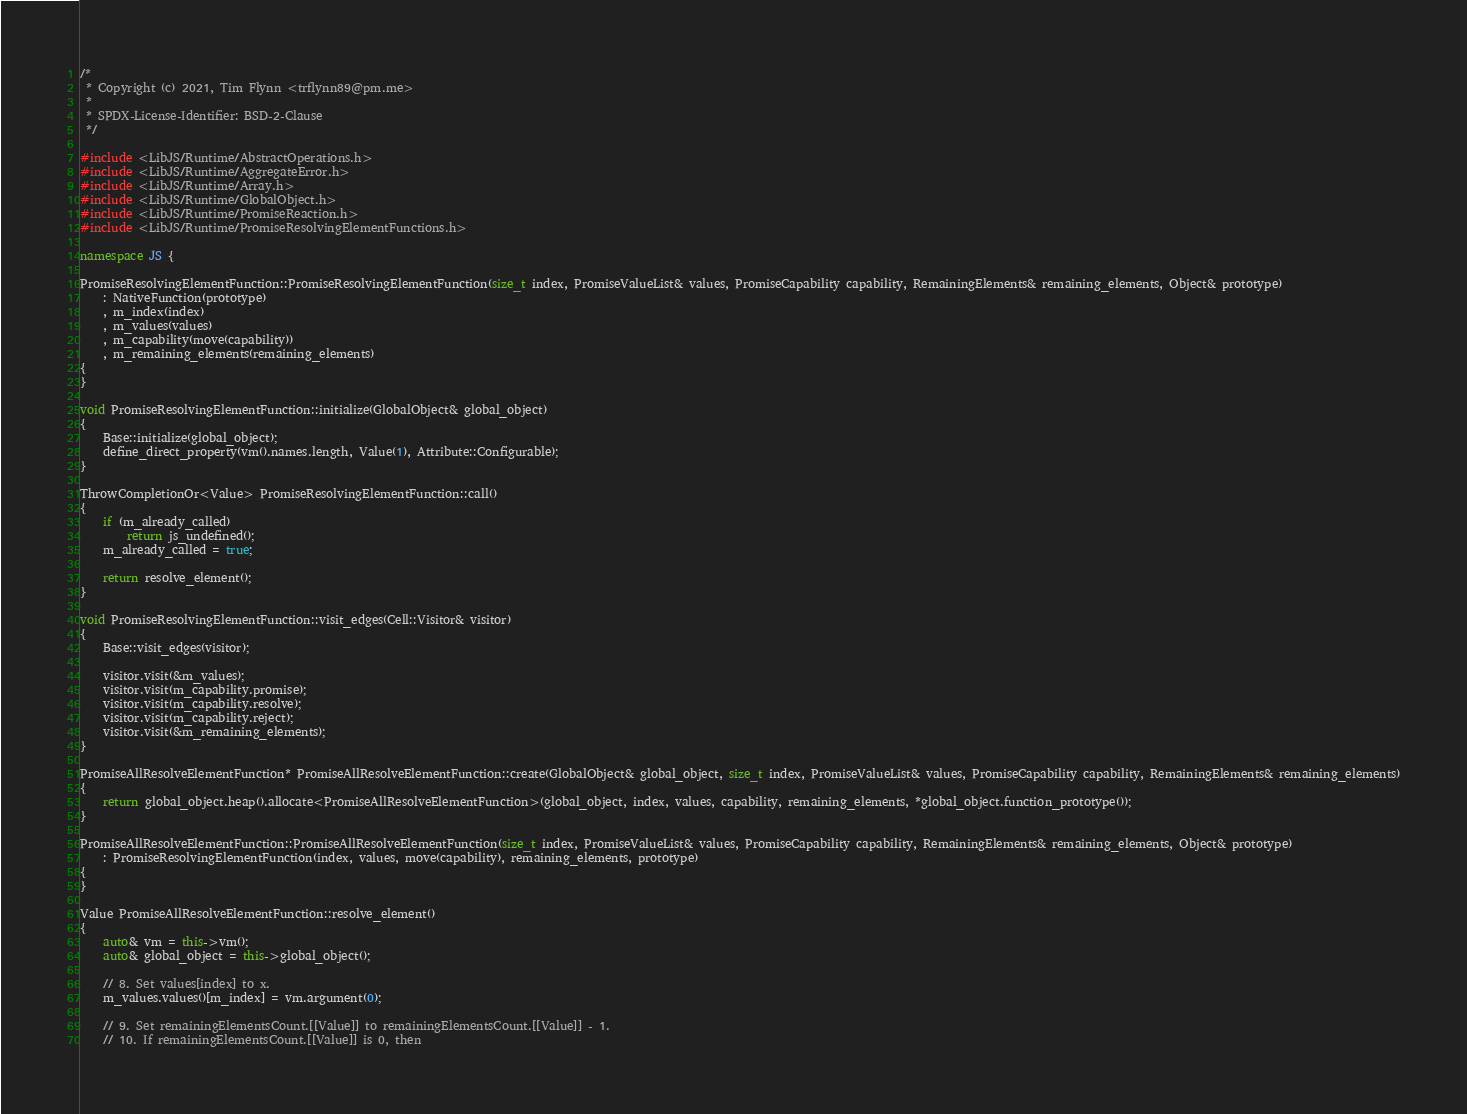<code> <loc_0><loc_0><loc_500><loc_500><_C++_>/*
 * Copyright (c) 2021, Tim Flynn <trflynn89@pm.me>
 *
 * SPDX-License-Identifier: BSD-2-Clause
 */

#include <LibJS/Runtime/AbstractOperations.h>
#include <LibJS/Runtime/AggregateError.h>
#include <LibJS/Runtime/Array.h>
#include <LibJS/Runtime/GlobalObject.h>
#include <LibJS/Runtime/PromiseReaction.h>
#include <LibJS/Runtime/PromiseResolvingElementFunctions.h>

namespace JS {

PromiseResolvingElementFunction::PromiseResolvingElementFunction(size_t index, PromiseValueList& values, PromiseCapability capability, RemainingElements& remaining_elements, Object& prototype)
    : NativeFunction(prototype)
    , m_index(index)
    , m_values(values)
    , m_capability(move(capability))
    , m_remaining_elements(remaining_elements)
{
}

void PromiseResolvingElementFunction::initialize(GlobalObject& global_object)
{
    Base::initialize(global_object);
    define_direct_property(vm().names.length, Value(1), Attribute::Configurable);
}

ThrowCompletionOr<Value> PromiseResolvingElementFunction::call()
{
    if (m_already_called)
        return js_undefined();
    m_already_called = true;

    return resolve_element();
}

void PromiseResolvingElementFunction::visit_edges(Cell::Visitor& visitor)
{
    Base::visit_edges(visitor);

    visitor.visit(&m_values);
    visitor.visit(m_capability.promise);
    visitor.visit(m_capability.resolve);
    visitor.visit(m_capability.reject);
    visitor.visit(&m_remaining_elements);
}

PromiseAllResolveElementFunction* PromiseAllResolveElementFunction::create(GlobalObject& global_object, size_t index, PromiseValueList& values, PromiseCapability capability, RemainingElements& remaining_elements)
{
    return global_object.heap().allocate<PromiseAllResolveElementFunction>(global_object, index, values, capability, remaining_elements, *global_object.function_prototype());
}

PromiseAllResolveElementFunction::PromiseAllResolveElementFunction(size_t index, PromiseValueList& values, PromiseCapability capability, RemainingElements& remaining_elements, Object& prototype)
    : PromiseResolvingElementFunction(index, values, move(capability), remaining_elements, prototype)
{
}

Value PromiseAllResolveElementFunction::resolve_element()
{
    auto& vm = this->vm();
    auto& global_object = this->global_object();

    // 8. Set values[index] to x.
    m_values.values()[m_index] = vm.argument(0);

    // 9. Set remainingElementsCount.[[Value]] to remainingElementsCount.[[Value]] - 1.
    // 10. If remainingElementsCount.[[Value]] is 0, then</code> 